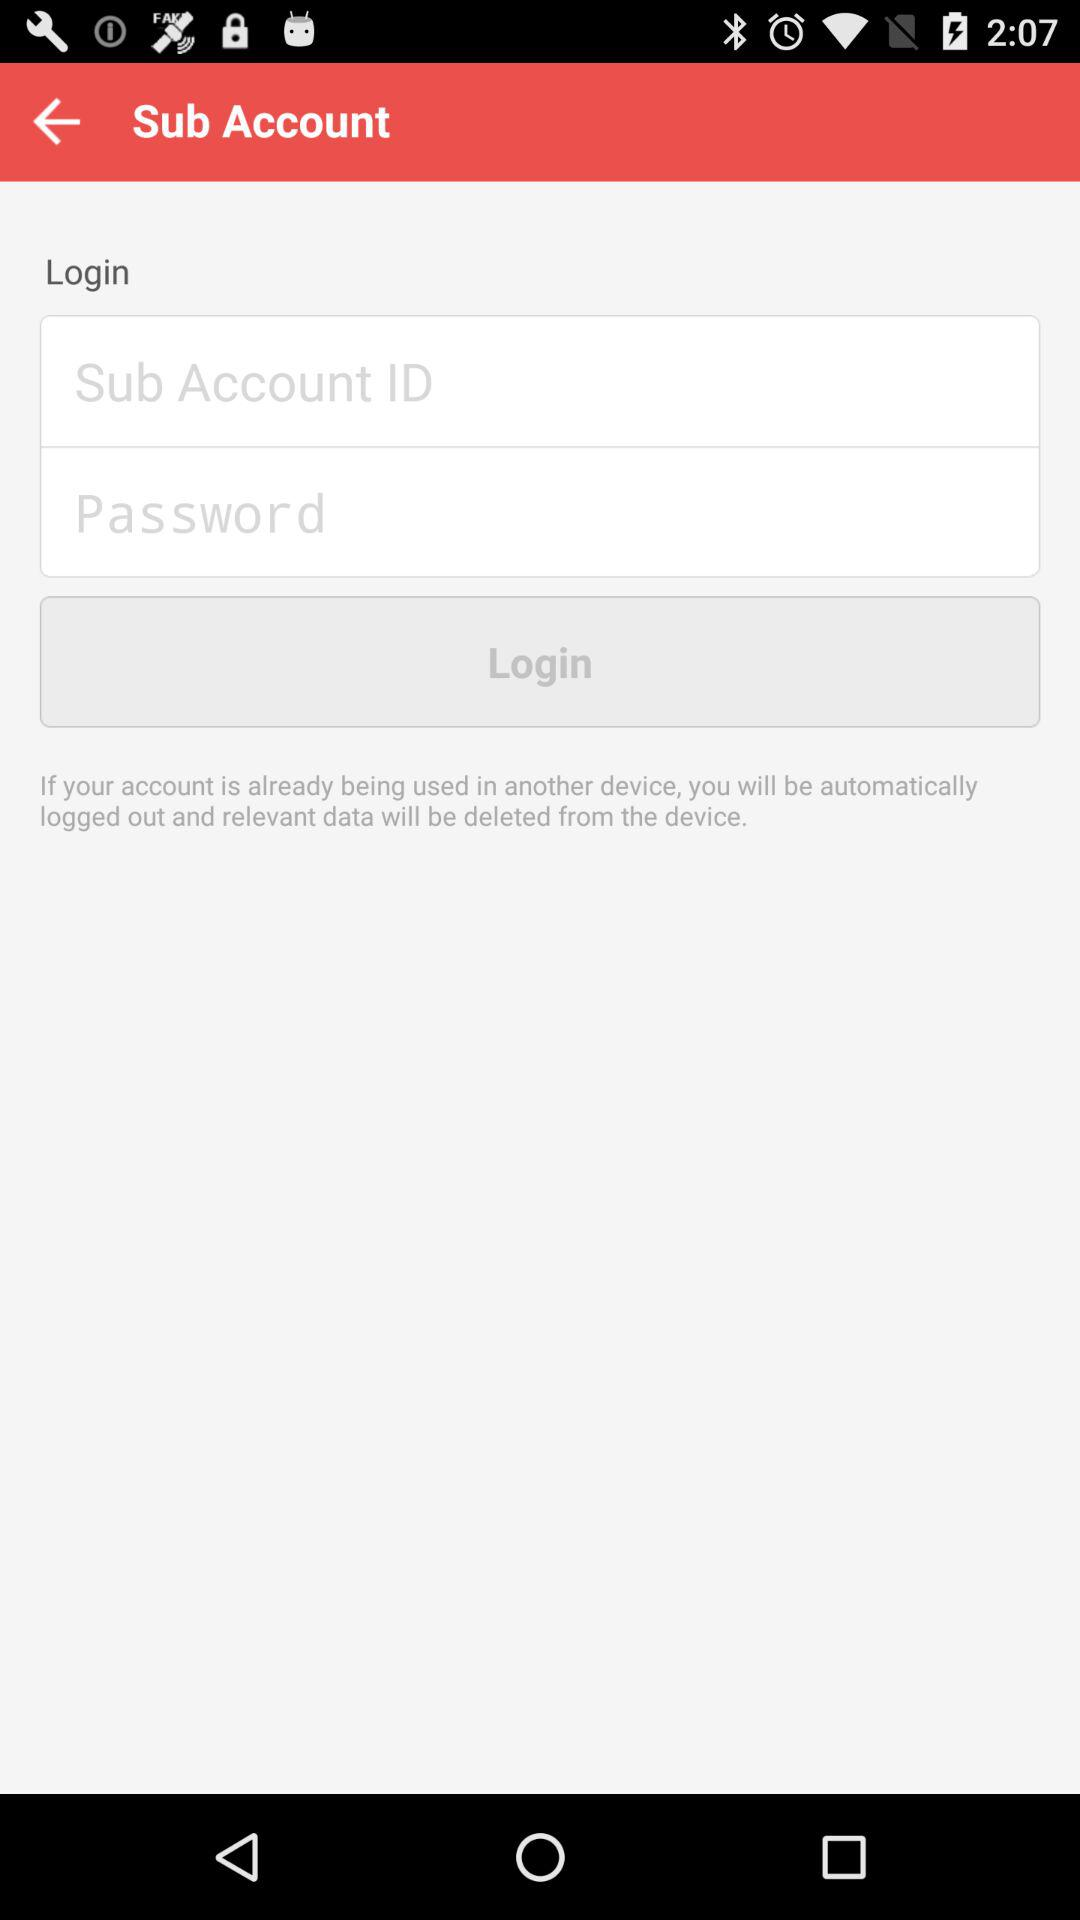What are the requirements to login? The requirements are "Sub Account ID" and "Password". 